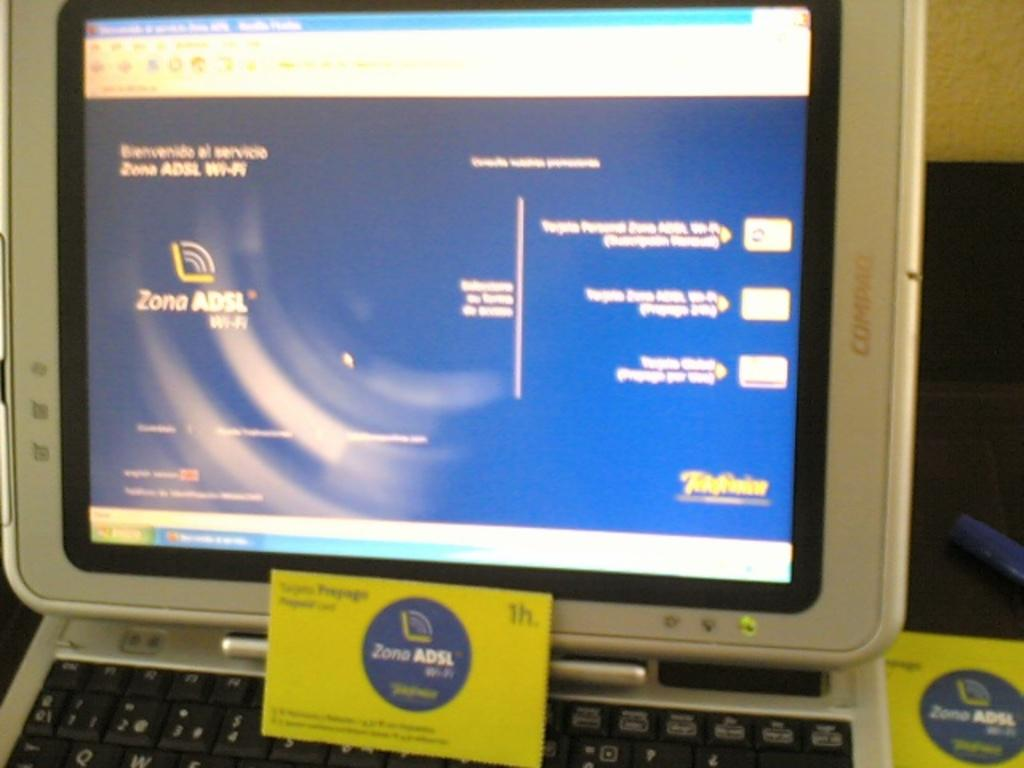Provide a one-sentence caption for the provided image. A Compaq screen displays information about Zona ADSL wi-fi. 